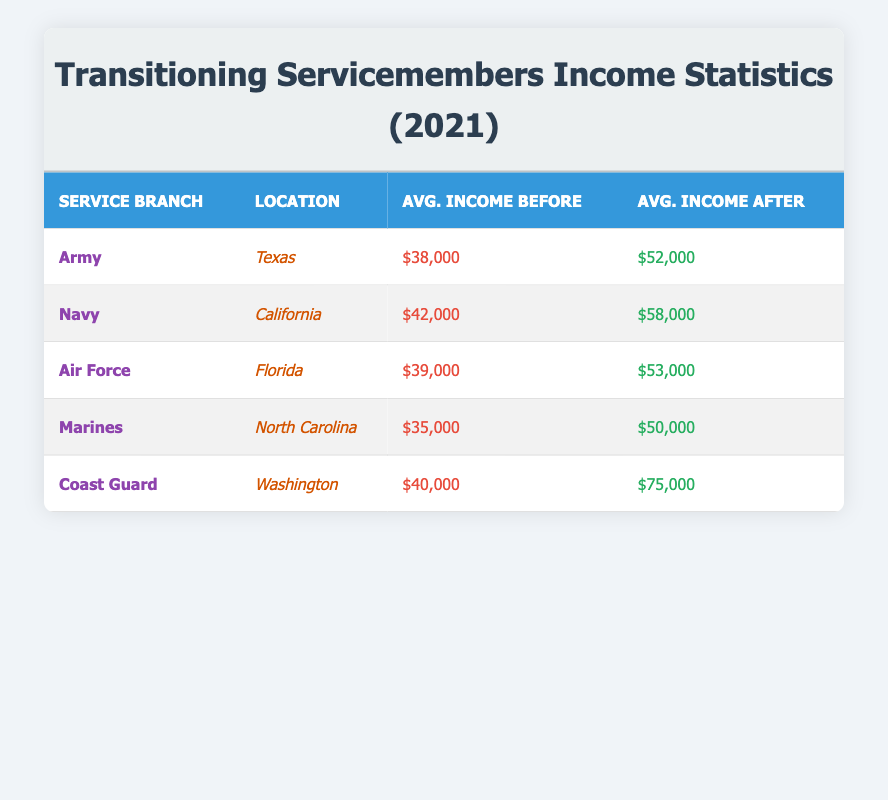What was the average income of transitioning servicemembers in the Army before utilization of non-profit services? From the table, the Army's average income before is listed as $38,000.
Answer: $38,000 Which service branch had the highest average income after utilizing non-profit services? Checking the 'Avg. Income After' column, the Coast Guard has the highest average income at $75,000.
Answer: Coast Guard What is the difference in average income before and after for transitioning servicemembers in the Marines? Calculating the difference for the Marines involves taking the after value ($50,000) and subtracting the before value ($35,000), yielding a difference of $15,000.
Answer: $15,000 Did servicemembers in the Air Force experience a greater increase in average income after utilizing non-profit services compared to those in the Navy? The Air Force average increased from $39,000 to $53,000 (an increase of $14,000), while the Navy increased from $42,000 to $58,000 (an increase of $16,000). Therefore, the Navy experienced a greater increase.
Answer: No What was the overall average income of transitioning servicemembers before utilizing non-profit services across all service branches listed? To find the overall average before income, sum all the 'Avg. Income Before' values: $38,000 + $42,000 + $39,000 + $35,000 + $40,000 = $194,000. Then, divide by the number of branches (5), resulting in $38,800.
Answer: $38,800 Which location had the lowest average income before and what was that amount? From the table, North Carolina's Marines had the lowest average income before, which was $35,000.
Answer: North Carolina, $35,000 Is it true that all service branches listed saw an increase in average income after utilizing the non-profit services? Reviewing the table, every branch's average income after is greater than before, confirming that all branches experienced an increase.
Answer: Yes What is the average income after for transitioning servicemembers in Texas and Florida combined? To find the average income after for Texas (Army, $52,000) and Florida (Air Force, $53,000), add $52,000 + $53,000 = $105,000 and then divide by 2, resulting in an average of $52,500.
Answer: $52,500 